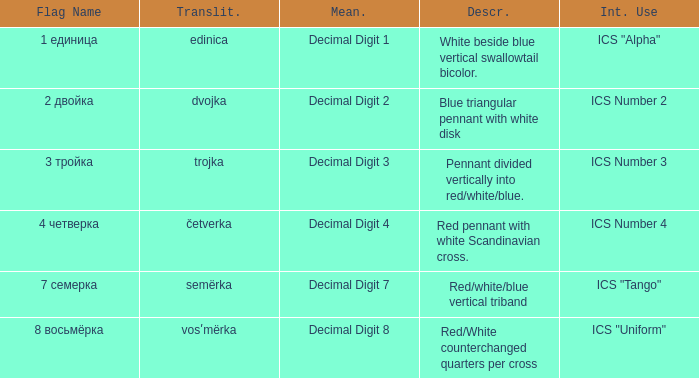What are the meanings of the flag whose name transliterates to dvojka? Decimal Digit 2. 